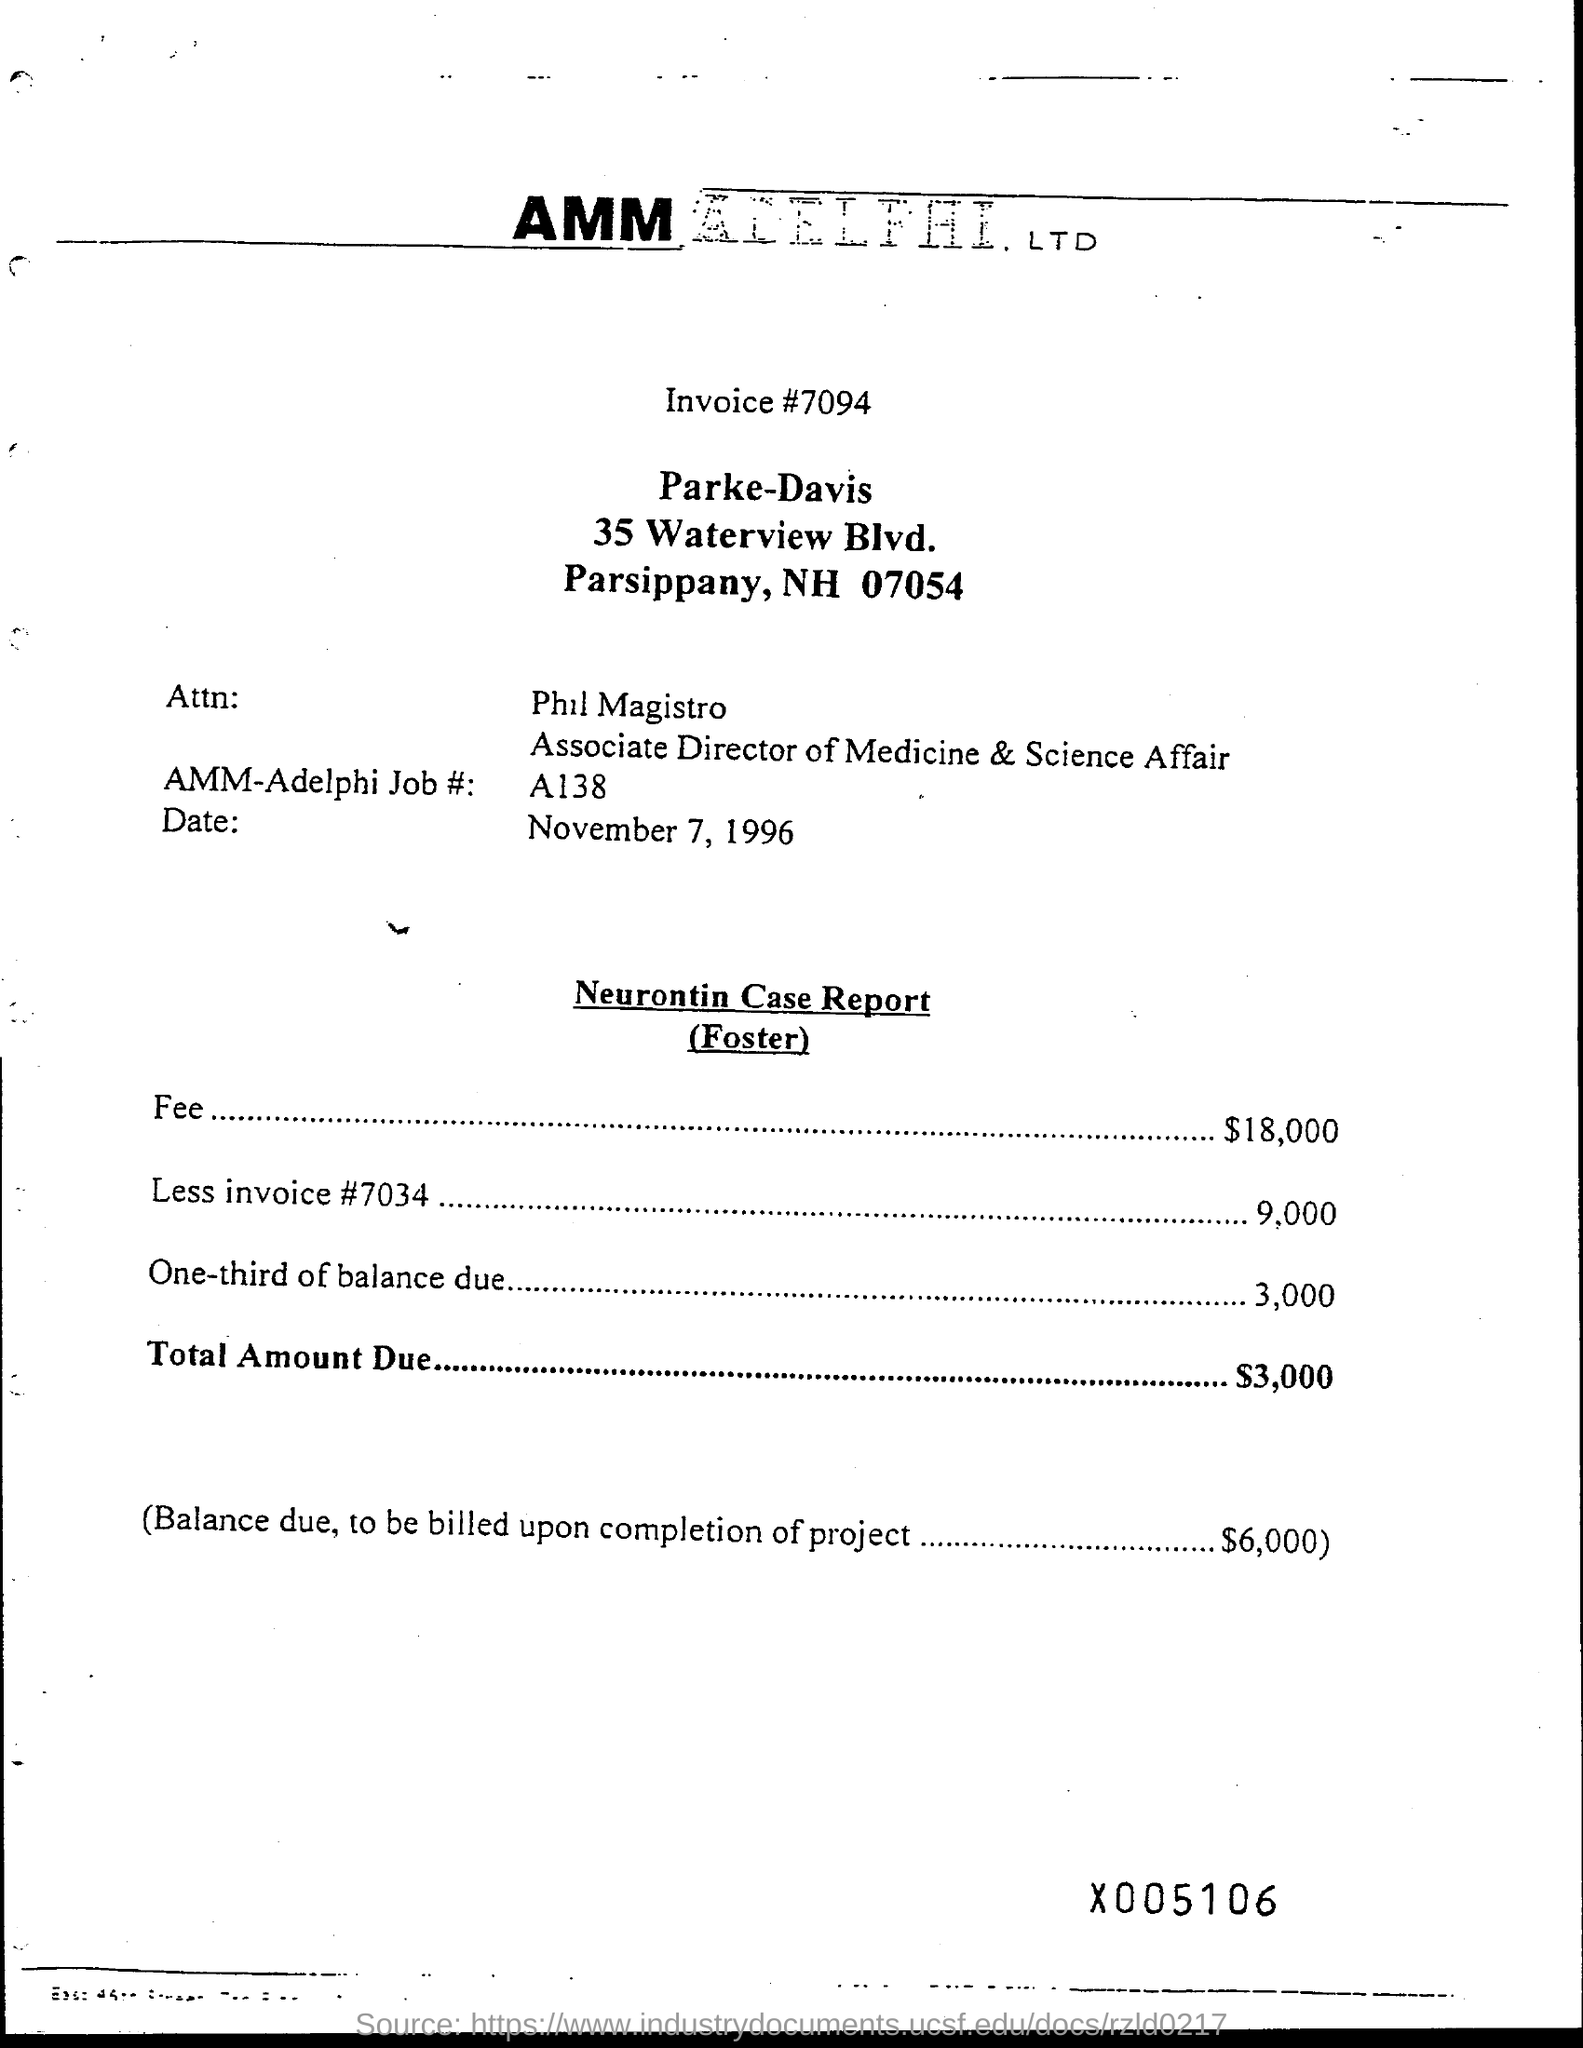What is fee amount?
Your response must be concise. 18,000. What is one-third of balance due?
Your answer should be compact. 3,000. What is total amount due?
Offer a very short reply. $3,000. 